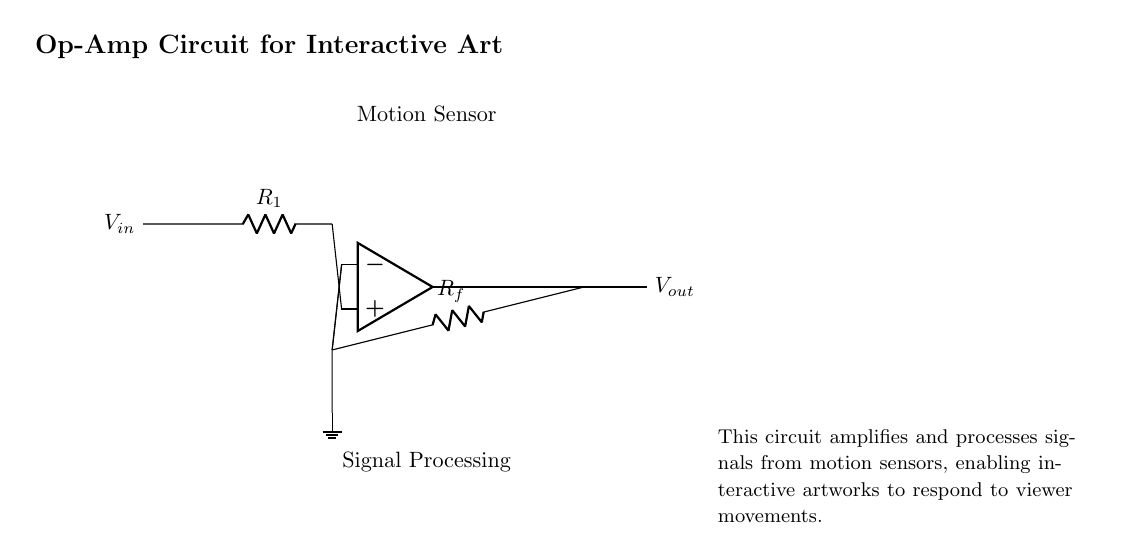What is the type of amplifier used in this circuit? The circuit uses an operational amplifier, which can be identified by the symbol shown. It is designed to amplify voltage signals.
Answer: operational amplifier What are the input and output voltages labeled in the circuit? The input voltage is labeled as \( V_{in} \), and the output voltage is labeled as \( V_{out} \), both indicated at the respective terminals.
Answer: \( V_{in} \) and \( V_{out} \) What component is connected to the non-inverting terminal of the op-amp? The resistor labeled \( R_1 \) is connected to the non-inverting terminal, which shows how input voltage is fed into the op-amp for processing.
Answer: \( R_1 \) What is the purpose of the feedback resistor \( R_f \)? The feedback resistor \( R_f \) connects the output back to the inverting terminal, allowing for gain control and stability in the amplification process.
Answer: gain control How does the motion sensor relate to the circuit? The motion sensor provides the input voltage \( V_{in} \) that is amplified by the op-amp circuit, making it essential for interaction based on viewer movements.
Answer: interaction What are the terminals of the op-amp used for? The op-amp's terminals include the non-inverting and inverting terminals, which are used for signal input and feedback, respectively, crucial for the amplification process.
Answer: signal processing and feedback What does the ground connection signify in this circuit? The ground connection signifies a reference point for the circuit's voltages, establishing a common return path for current and ensuring proper operation of the amplifier.
Answer: reference point 